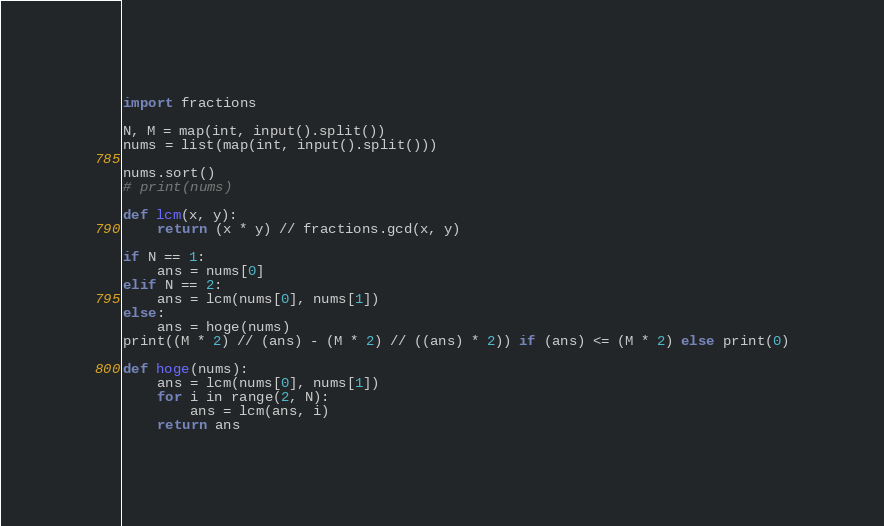<code> <loc_0><loc_0><loc_500><loc_500><_Python_>import fractions

N, M = map(int, input().split())
nums = list(map(int, input().split()))

nums.sort()
# print(nums)

def lcm(x, y):
    return (x * y) // fractions.gcd(x, y)

if N == 1:
    ans = nums[0]
elif N == 2:
    ans = lcm(nums[0], nums[1])
else:
    ans = hoge(nums)
print((M * 2) // (ans) - (M * 2) // ((ans) * 2)) if (ans) <= (M * 2) else print(0)

def hoge(nums):
    ans = lcm(nums[0], nums[1])
    for i in range(2, N):
        ans = lcm(ans, i)
    return ans</code> 